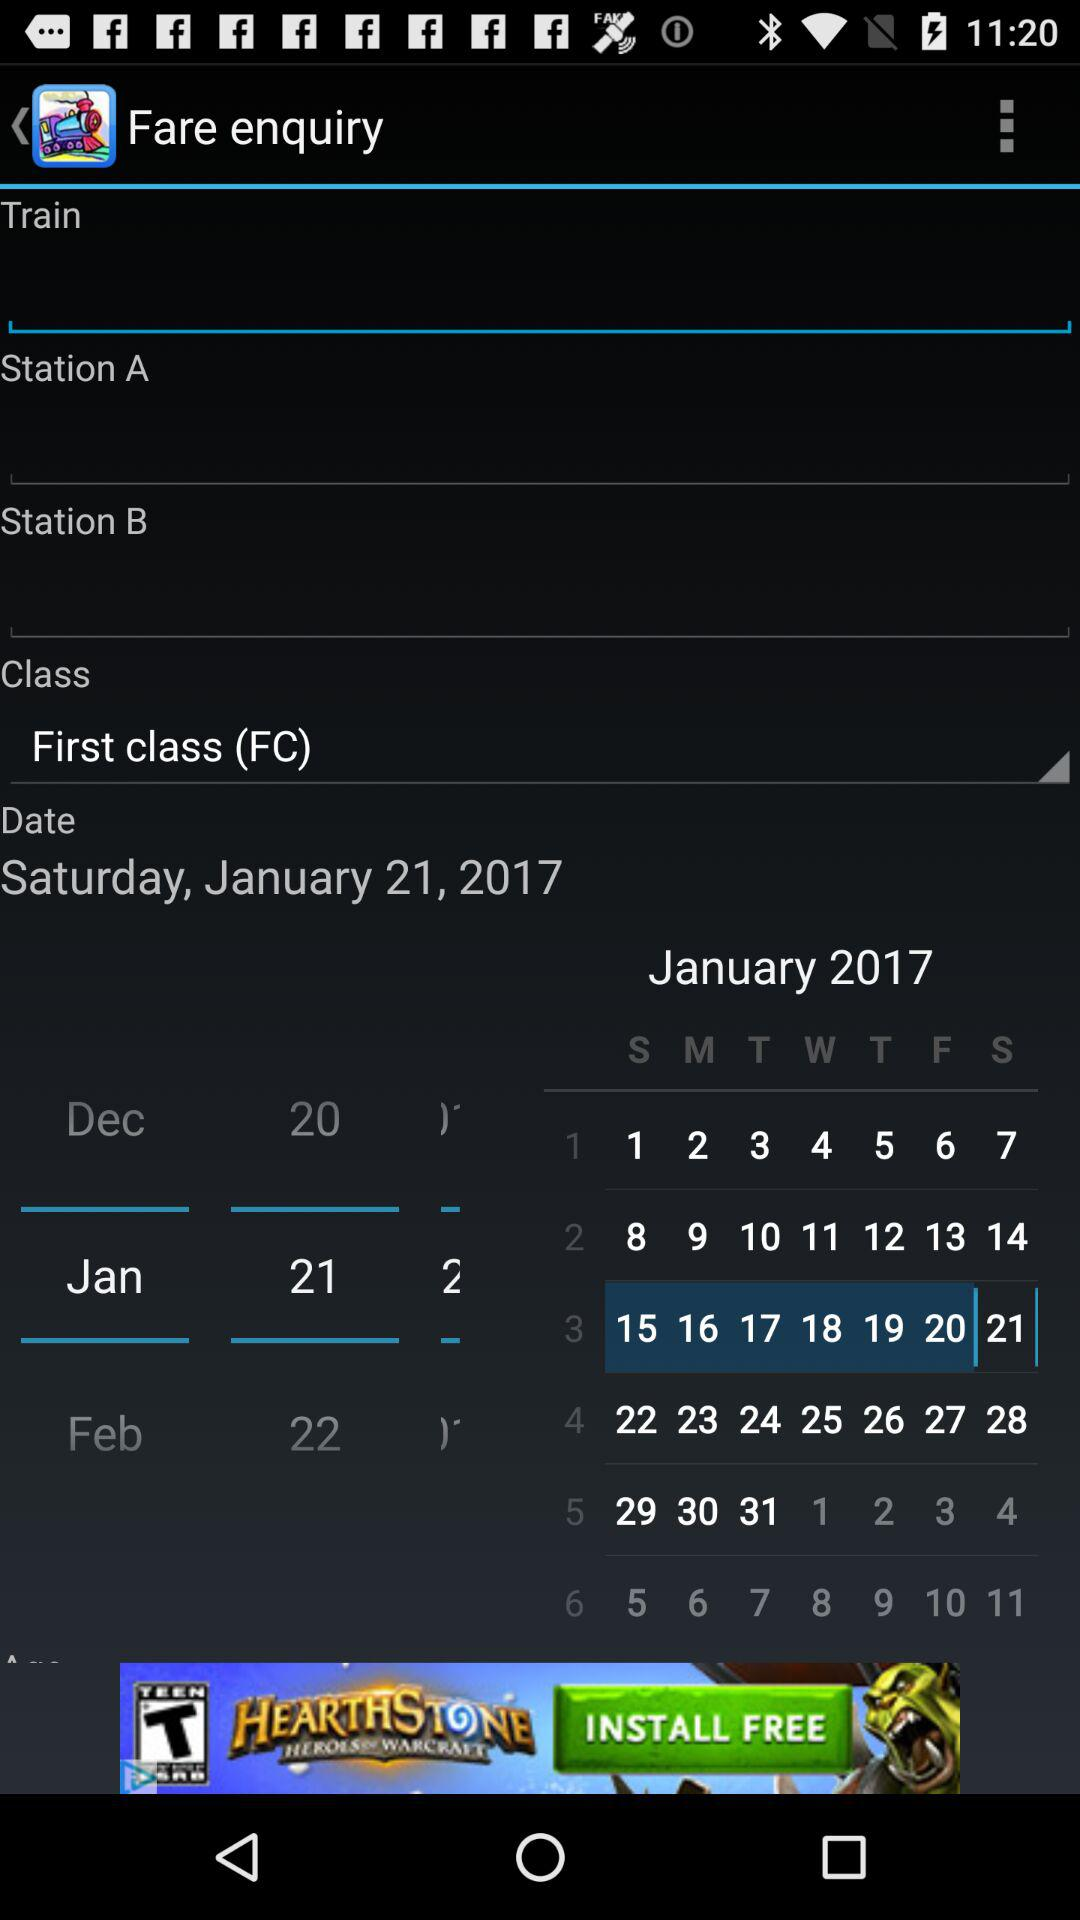Which train class is selected? The selected train class is "First class (FC)". 